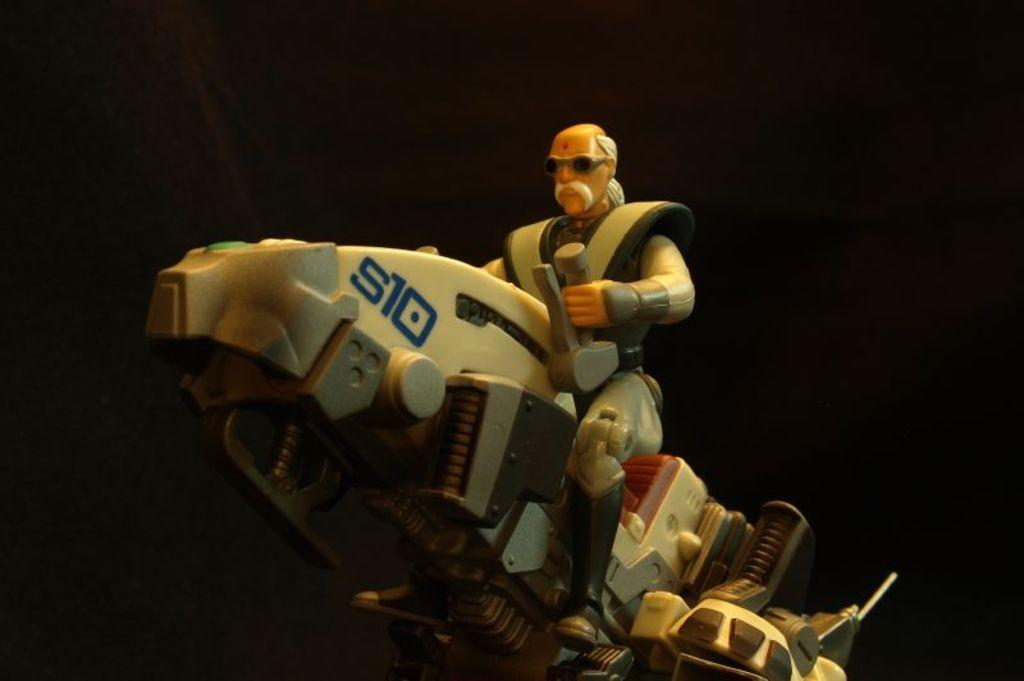What type of toy can be seen in the image? There is a toy car and a toy robot in the image. How are the toys positioned in relation to each other? The toy robot is sitting on the toy car. What type of destruction can be seen in the image? There is no destruction present in the image; it features a toy car and a toy robot in a non-destructive setting. What type of musical instrument is being played by the toy robot in the image? There is no musical instrument, such as a drum, present in the image. 